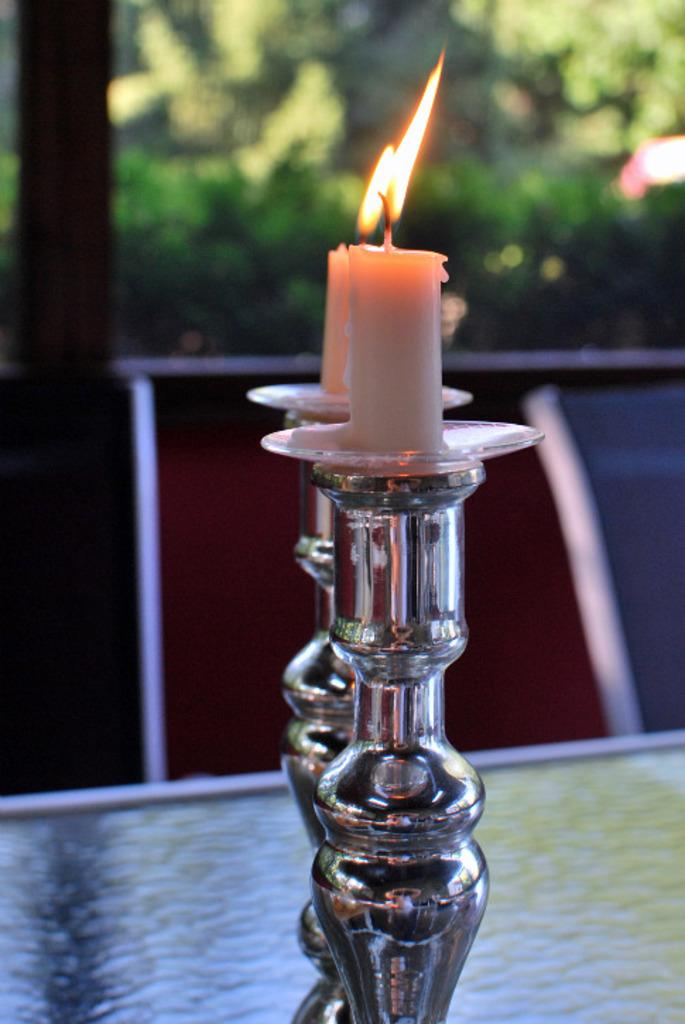How many candles are in the image? There are two candles in the image. What are the candles placed on? The candles are placed on stands. Where are the stands located? The stands are placed on a platform. What can be seen in the background of the image? There are trees visible in the background of the image. What type of substance is being used to provide comfort in the image? There is no substance being used to provide comfort in the image; it features two candles on stands placed on a platform with trees visible in the background. 